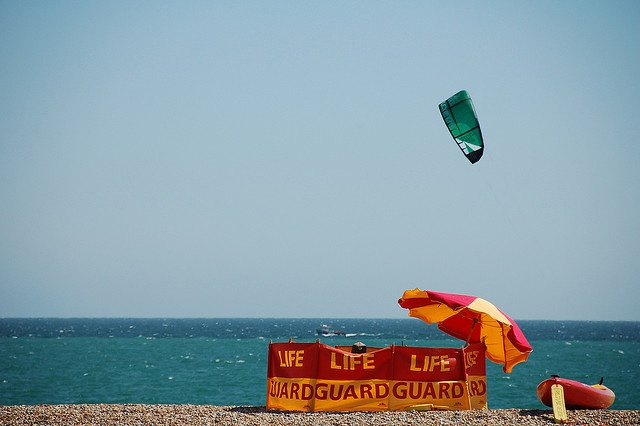Describe the objects in this image and their specific colors. I can see umbrella in gray, maroon, red, and orange tones, kite in gray, teal, black, and darkgreen tones, boat in gray, maroon, brown, black, and salmon tones, and boat in gray, blue, and navy tones in this image. 